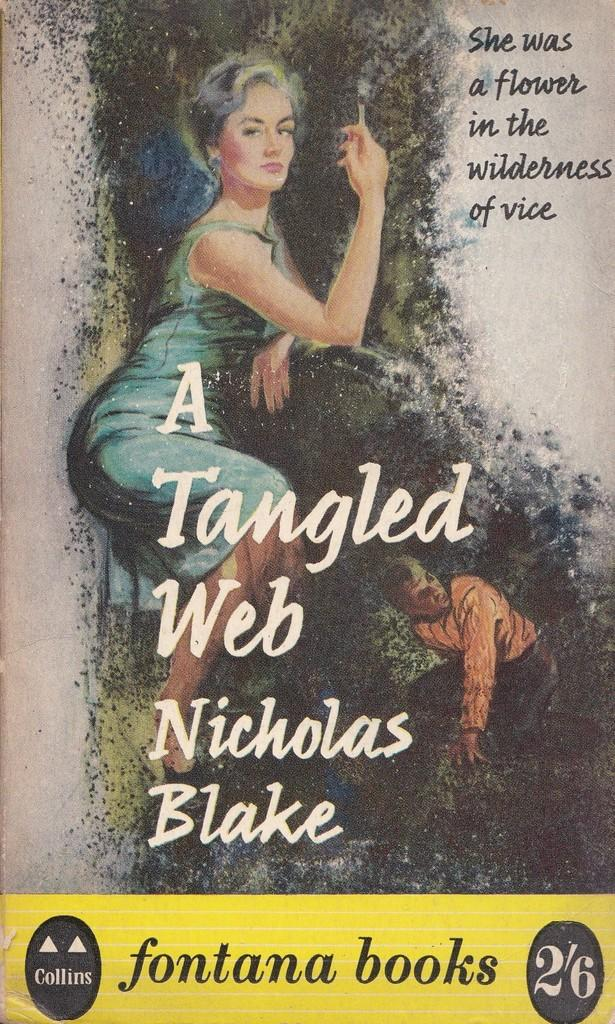<image>
Describe the image concisely. The cover of a book titled A tangled Web. 